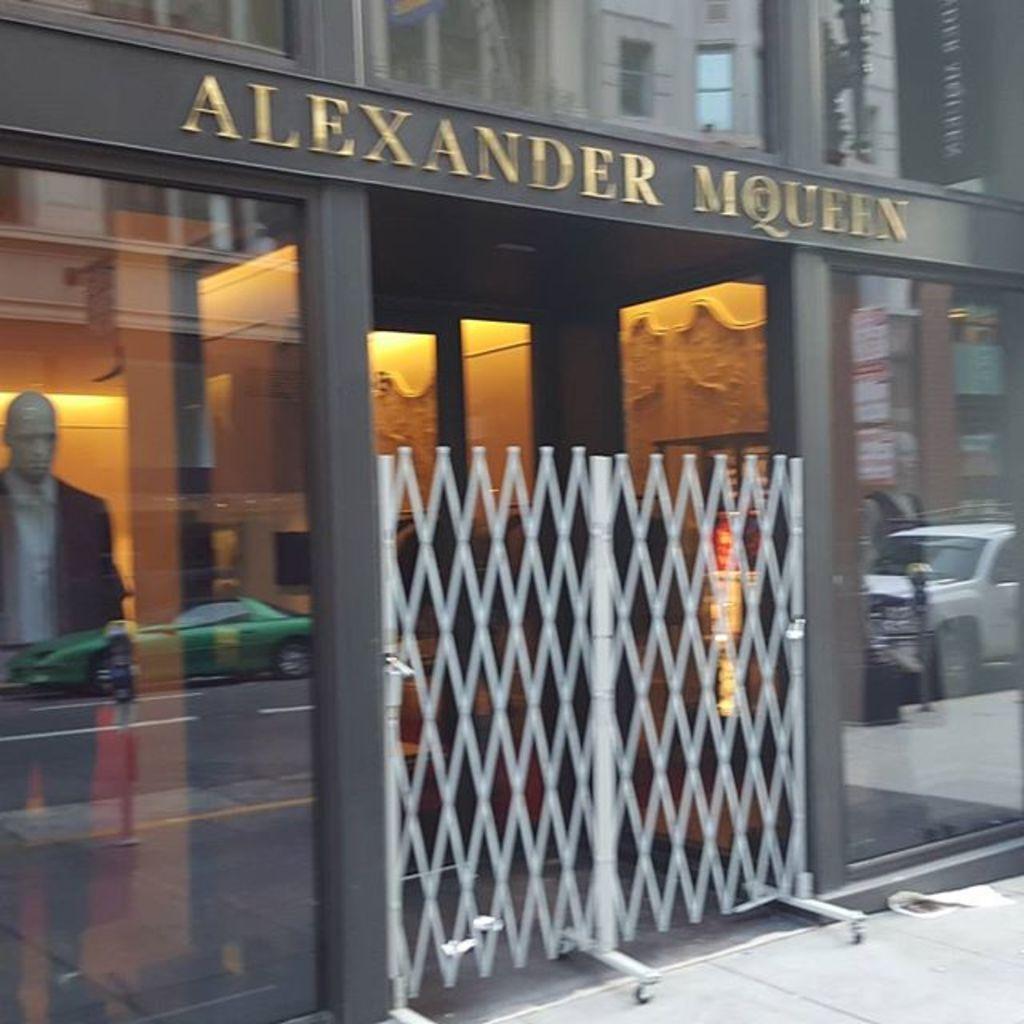Please provide a concise description of this image. This image is taken outdoors. At the bottom of the image there is a floor. In the middle of the image there is a building with glass doors. There is a railing. There is a mannequin with a suit, a shirt and a pant. We can see the shadows of two cars on the glass doors. 